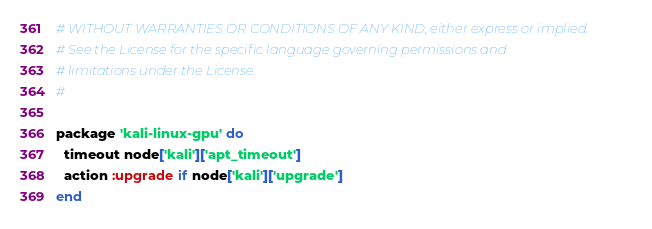<code> <loc_0><loc_0><loc_500><loc_500><_Ruby_># WITHOUT WARRANTIES OR CONDITIONS OF ANY KIND, either express or implied.
# See the License for the specific language governing permissions and
# limitations under the License.
#

package 'kali-linux-gpu' do
  timeout node['kali']['apt_timeout']
  action :upgrade if node['kali']['upgrade']
end
</code> 